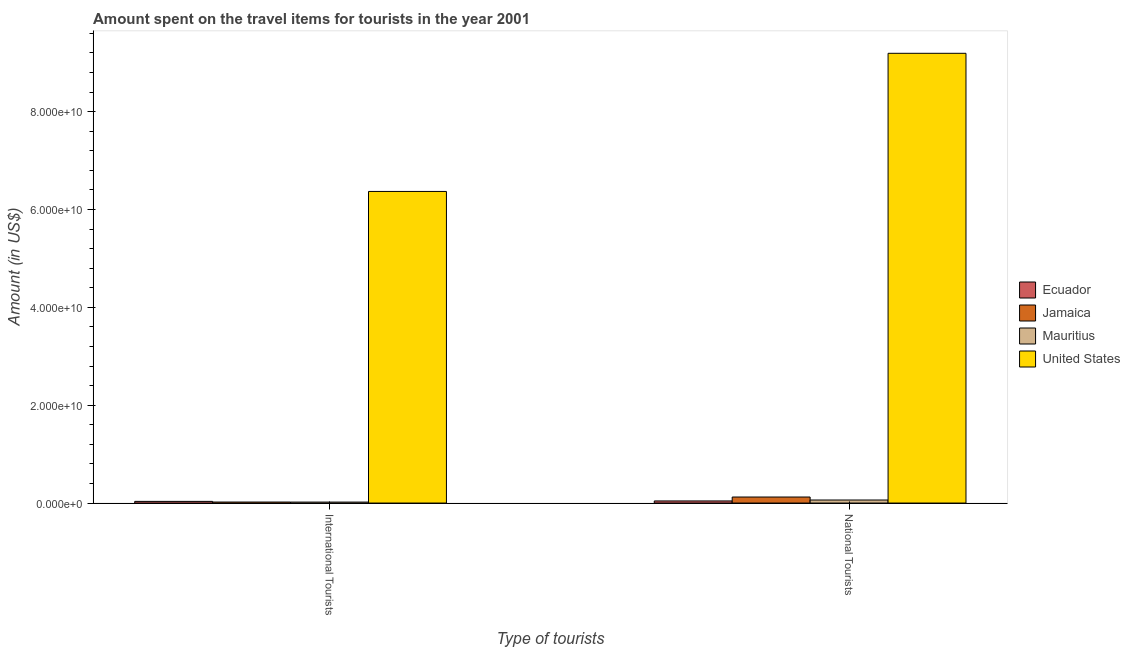Are the number of bars per tick equal to the number of legend labels?
Your response must be concise. Yes. Are the number of bars on each tick of the X-axis equal?
Provide a short and direct response. Yes. How many bars are there on the 2nd tick from the right?
Give a very brief answer. 4. What is the label of the 2nd group of bars from the left?
Provide a succinct answer. National Tourists. What is the amount spent on travel items of national tourists in United States?
Your answer should be very brief. 9.19e+1. Across all countries, what is the maximum amount spent on travel items of international tourists?
Your response must be concise. 6.37e+1. Across all countries, what is the minimum amount spent on travel items of international tourists?
Provide a succinct answer. 1.98e+08. In which country was the amount spent on travel items of national tourists maximum?
Offer a terse response. United States. In which country was the amount spent on travel items of national tourists minimum?
Give a very brief answer. Ecuador. What is the total amount spent on travel items of national tourists in the graph?
Keep it short and to the point. 9.42e+1. What is the difference between the amount spent on travel items of international tourists in Mauritius and that in Jamaica?
Provide a short and direct response. -8.00e+06. What is the difference between the amount spent on travel items of international tourists in Ecuador and the amount spent on travel items of national tourists in Jamaica?
Provide a succinct answer. -8.92e+08. What is the average amount spent on travel items of international tourists per country?
Offer a terse response. 1.61e+1. What is the difference between the amount spent on travel items of national tourists and amount spent on travel items of international tourists in Ecuador?
Give a very brief answer. 9.00e+07. In how many countries, is the amount spent on travel items of international tourists greater than 92000000000 US$?
Keep it short and to the point. 0. What is the ratio of the amount spent on travel items of national tourists in Ecuador to that in United States?
Your response must be concise. 0. Is the amount spent on travel items of national tourists in Ecuador less than that in Mauritius?
Give a very brief answer. Yes. What does the 3rd bar from the left in National Tourists represents?
Your response must be concise. Mauritius. Are all the bars in the graph horizontal?
Your answer should be very brief. No. How many countries are there in the graph?
Provide a short and direct response. 4. Does the graph contain any zero values?
Provide a short and direct response. No. Does the graph contain grids?
Keep it short and to the point. No. Where does the legend appear in the graph?
Give a very brief answer. Center right. How are the legend labels stacked?
Keep it short and to the point. Vertical. What is the title of the graph?
Provide a short and direct response. Amount spent on the travel items for tourists in the year 2001. What is the label or title of the X-axis?
Your answer should be very brief. Type of tourists. What is the label or title of the Y-axis?
Provide a short and direct response. Amount (in US$). What is the Amount (in US$) of Ecuador in International Tourists?
Offer a terse response. 3.40e+08. What is the Amount (in US$) of Jamaica in International Tourists?
Your answer should be compact. 2.06e+08. What is the Amount (in US$) in Mauritius in International Tourists?
Provide a succinct answer. 1.98e+08. What is the Amount (in US$) in United States in International Tourists?
Make the answer very short. 6.37e+1. What is the Amount (in US$) in Ecuador in National Tourists?
Provide a short and direct response. 4.30e+08. What is the Amount (in US$) in Jamaica in National Tourists?
Your response must be concise. 1.23e+09. What is the Amount (in US$) in Mauritius in National Tourists?
Your answer should be compact. 6.23e+08. What is the Amount (in US$) in United States in National Tourists?
Make the answer very short. 9.19e+1. Across all Type of tourists, what is the maximum Amount (in US$) of Ecuador?
Make the answer very short. 4.30e+08. Across all Type of tourists, what is the maximum Amount (in US$) of Jamaica?
Give a very brief answer. 1.23e+09. Across all Type of tourists, what is the maximum Amount (in US$) of Mauritius?
Make the answer very short. 6.23e+08. Across all Type of tourists, what is the maximum Amount (in US$) of United States?
Ensure brevity in your answer.  9.19e+1. Across all Type of tourists, what is the minimum Amount (in US$) of Ecuador?
Give a very brief answer. 3.40e+08. Across all Type of tourists, what is the minimum Amount (in US$) of Jamaica?
Your answer should be compact. 2.06e+08. Across all Type of tourists, what is the minimum Amount (in US$) in Mauritius?
Provide a short and direct response. 1.98e+08. Across all Type of tourists, what is the minimum Amount (in US$) in United States?
Your response must be concise. 6.37e+1. What is the total Amount (in US$) of Ecuador in the graph?
Provide a short and direct response. 7.70e+08. What is the total Amount (in US$) in Jamaica in the graph?
Your answer should be compact. 1.44e+09. What is the total Amount (in US$) in Mauritius in the graph?
Give a very brief answer. 8.21e+08. What is the total Amount (in US$) of United States in the graph?
Provide a succinct answer. 1.56e+11. What is the difference between the Amount (in US$) in Ecuador in International Tourists and that in National Tourists?
Provide a succinct answer. -9.00e+07. What is the difference between the Amount (in US$) of Jamaica in International Tourists and that in National Tourists?
Provide a succinct answer. -1.03e+09. What is the difference between the Amount (in US$) in Mauritius in International Tourists and that in National Tourists?
Your answer should be compact. -4.25e+08. What is the difference between the Amount (in US$) of United States in International Tourists and that in National Tourists?
Your response must be concise. -2.82e+1. What is the difference between the Amount (in US$) of Ecuador in International Tourists and the Amount (in US$) of Jamaica in National Tourists?
Provide a short and direct response. -8.92e+08. What is the difference between the Amount (in US$) of Ecuador in International Tourists and the Amount (in US$) of Mauritius in National Tourists?
Your answer should be very brief. -2.83e+08. What is the difference between the Amount (in US$) in Ecuador in International Tourists and the Amount (in US$) in United States in National Tourists?
Your response must be concise. -9.16e+1. What is the difference between the Amount (in US$) in Jamaica in International Tourists and the Amount (in US$) in Mauritius in National Tourists?
Your response must be concise. -4.17e+08. What is the difference between the Amount (in US$) of Jamaica in International Tourists and the Amount (in US$) of United States in National Tourists?
Give a very brief answer. -9.17e+1. What is the difference between the Amount (in US$) in Mauritius in International Tourists and the Amount (in US$) in United States in National Tourists?
Ensure brevity in your answer.  -9.17e+1. What is the average Amount (in US$) of Ecuador per Type of tourists?
Offer a very short reply. 3.85e+08. What is the average Amount (in US$) of Jamaica per Type of tourists?
Offer a very short reply. 7.19e+08. What is the average Amount (in US$) in Mauritius per Type of tourists?
Offer a very short reply. 4.10e+08. What is the average Amount (in US$) in United States per Type of tourists?
Provide a short and direct response. 7.78e+1. What is the difference between the Amount (in US$) of Ecuador and Amount (in US$) of Jamaica in International Tourists?
Keep it short and to the point. 1.34e+08. What is the difference between the Amount (in US$) in Ecuador and Amount (in US$) in Mauritius in International Tourists?
Keep it short and to the point. 1.42e+08. What is the difference between the Amount (in US$) of Ecuador and Amount (in US$) of United States in International Tourists?
Provide a short and direct response. -6.33e+1. What is the difference between the Amount (in US$) in Jamaica and Amount (in US$) in Mauritius in International Tourists?
Provide a succinct answer. 8.00e+06. What is the difference between the Amount (in US$) of Jamaica and Amount (in US$) of United States in International Tourists?
Ensure brevity in your answer.  -6.35e+1. What is the difference between the Amount (in US$) of Mauritius and Amount (in US$) of United States in International Tourists?
Provide a short and direct response. -6.35e+1. What is the difference between the Amount (in US$) in Ecuador and Amount (in US$) in Jamaica in National Tourists?
Offer a very short reply. -8.02e+08. What is the difference between the Amount (in US$) of Ecuador and Amount (in US$) of Mauritius in National Tourists?
Provide a succinct answer. -1.93e+08. What is the difference between the Amount (in US$) of Ecuador and Amount (in US$) of United States in National Tourists?
Offer a very short reply. -9.15e+1. What is the difference between the Amount (in US$) in Jamaica and Amount (in US$) in Mauritius in National Tourists?
Make the answer very short. 6.09e+08. What is the difference between the Amount (in US$) of Jamaica and Amount (in US$) of United States in National Tourists?
Your answer should be compact. -9.07e+1. What is the difference between the Amount (in US$) of Mauritius and Amount (in US$) of United States in National Tourists?
Offer a very short reply. -9.13e+1. What is the ratio of the Amount (in US$) of Ecuador in International Tourists to that in National Tourists?
Provide a short and direct response. 0.79. What is the ratio of the Amount (in US$) in Jamaica in International Tourists to that in National Tourists?
Your response must be concise. 0.17. What is the ratio of the Amount (in US$) in Mauritius in International Tourists to that in National Tourists?
Keep it short and to the point. 0.32. What is the ratio of the Amount (in US$) of United States in International Tourists to that in National Tourists?
Your response must be concise. 0.69. What is the difference between the highest and the second highest Amount (in US$) in Ecuador?
Make the answer very short. 9.00e+07. What is the difference between the highest and the second highest Amount (in US$) of Jamaica?
Make the answer very short. 1.03e+09. What is the difference between the highest and the second highest Amount (in US$) of Mauritius?
Your answer should be compact. 4.25e+08. What is the difference between the highest and the second highest Amount (in US$) in United States?
Give a very brief answer. 2.82e+1. What is the difference between the highest and the lowest Amount (in US$) in Ecuador?
Your response must be concise. 9.00e+07. What is the difference between the highest and the lowest Amount (in US$) in Jamaica?
Offer a terse response. 1.03e+09. What is the difference between the highest and the lowest Amount (in US$) of Mauritius?
Make the answer very short. 4.25e+08. What is the difference between the highest and the lowest Amount (in US$) in United States?
Offer a very short reply. 2.82e+1. 